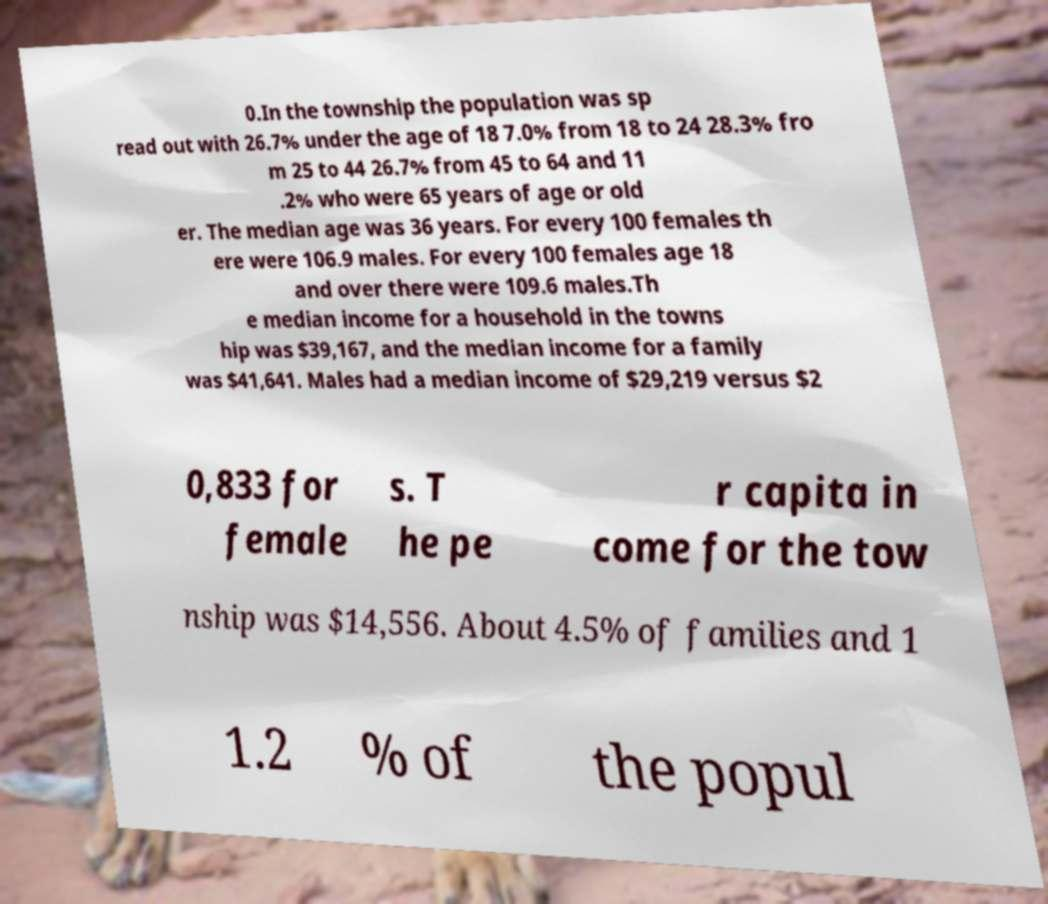I need the written content from this picture converted into text. Can you do that? 0.In the township the population was sp read out with 26.7% under the age of 18 7.0% from 18 to 24 28.3% fro m 25 to 44 26.7% from 45 to 64 and 11 .2% who were 65 years of age or old er. The median age was 36 years. For every 100 females th ere were 106.9 males. For every 100 females age 18 and over there were 109.6 males.Th e median income for a household in the towns hip was $39,167, and the median income for a family was $41,641. Males had a median income of $29,219 versus $2 0,833 for female s. T he pe r capita in come for the tow nship was $14,556. About 4.5% of families and 1 1.2 % of the popul 